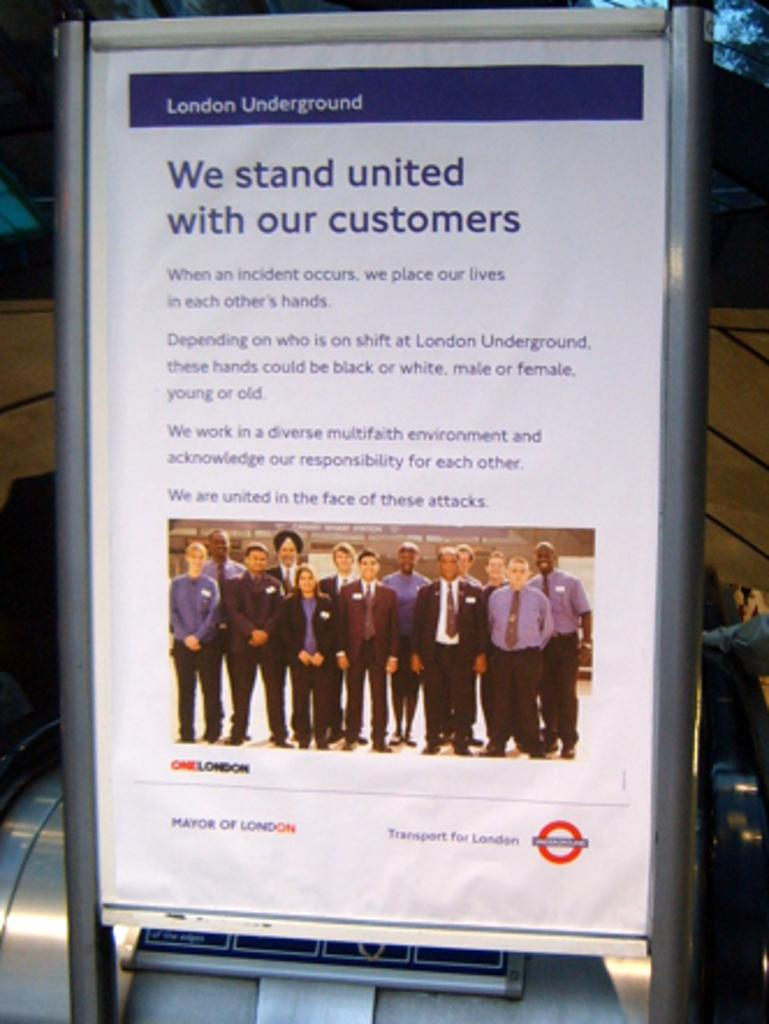<image>
Describe the image concisely. An advertisement message from employees of the London Underground gives assurance to customers. 